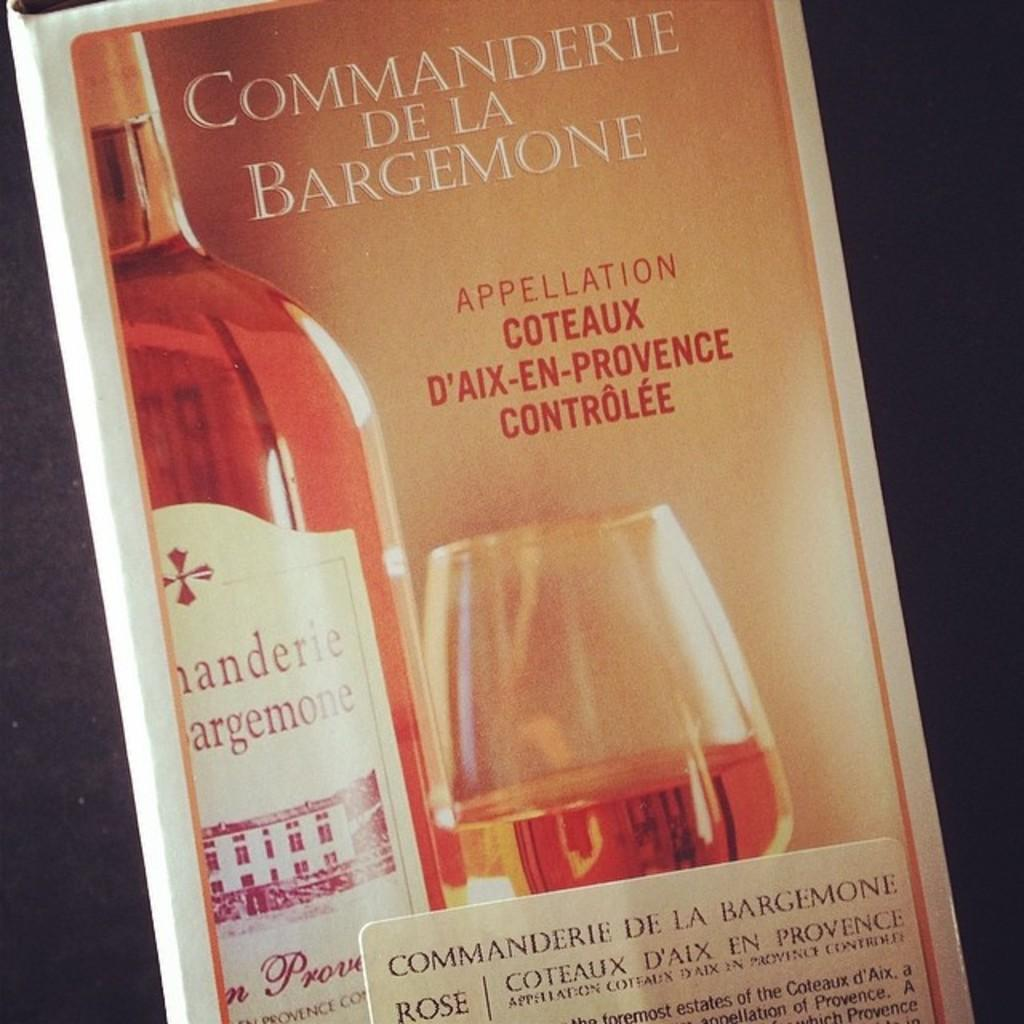Provide a one-sentence caption for the provided image. A box of wine called Commanderie De La Bargemone. 